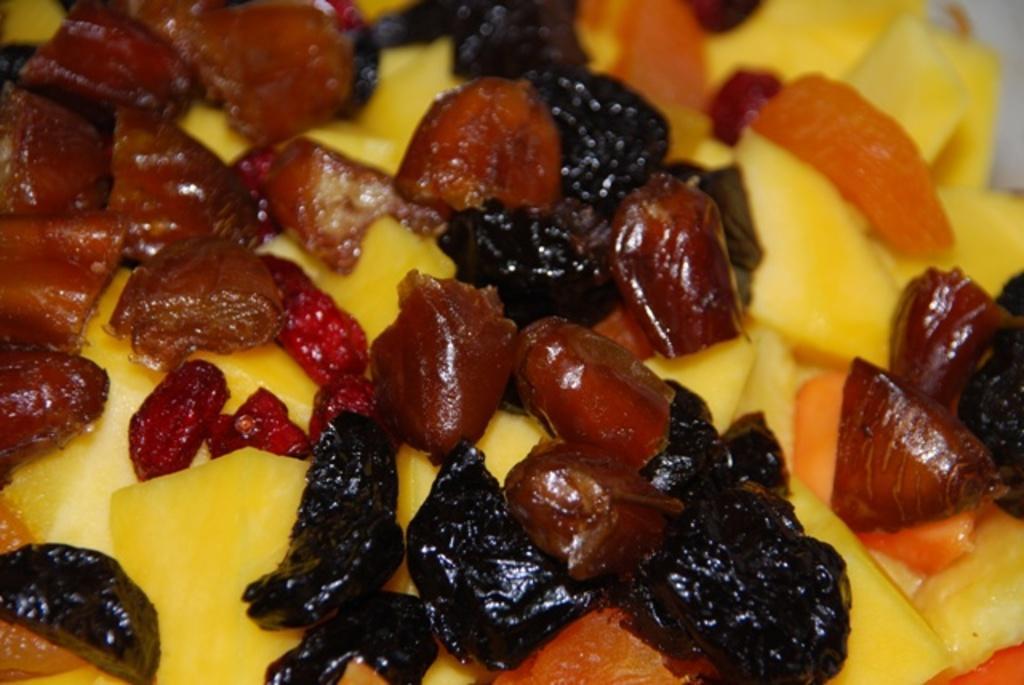In one or two sentences, can you explain what this image depicts? In this image we can see there are some fruits. 